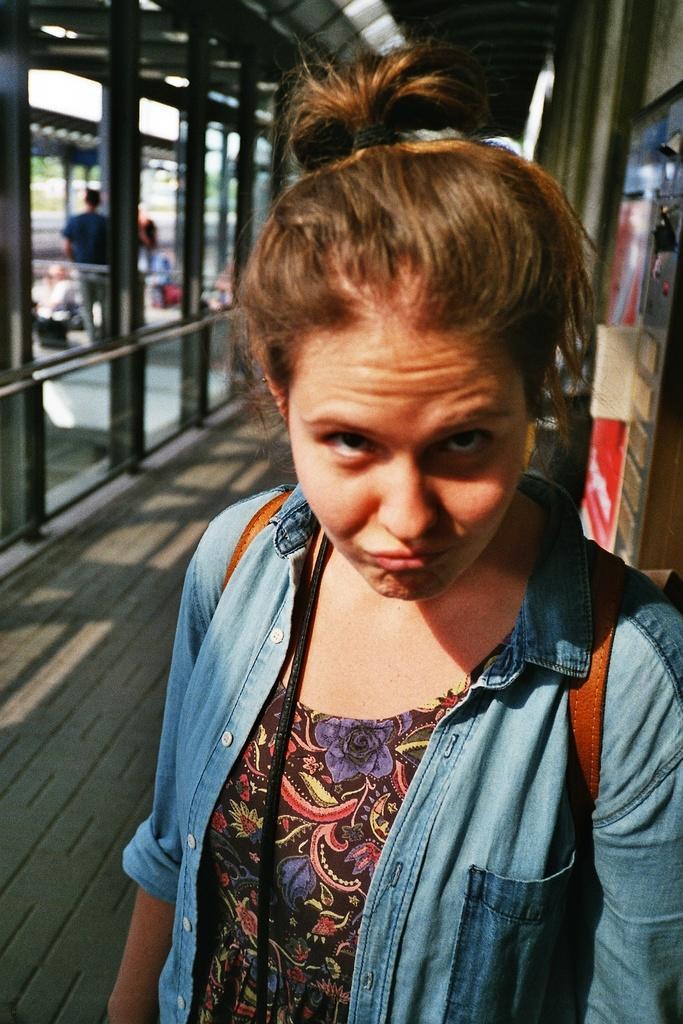In one or two sentences, can you explain what this image depicts? In the image there is a woman in the foreground and behind the women there are some poles and behind the poles there are other people. 